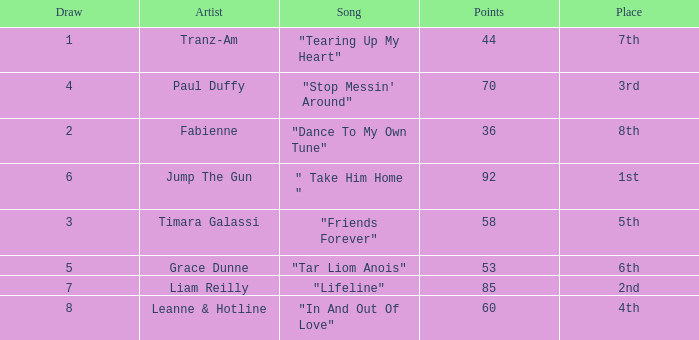Can you parse all the data within this table? {'header': ['Draw', 'Artist', 'Song', 'Points', 'Place'], 'rows': [['1', 'Tranz-Am', '"Tearing Up My Heart"', '44', '7th'], ['4', 'Paul Duffy', '"Stop Messin\' Around"', '70', '3rd'], ['2', 'Fabienne', '"Dance To My Own Tune"', '36', '8th'], ['6', 'Jump The Gun', '" Take Him Home "', '92', '1st'], ['3', 'Timara Galassi', '"Friends Forever"', '58', '5th'], ['5', 'Grace Dunne', '"Tar Liom Anois"', '53', '6th'], ['7', 'Liam Reilly', '"Lifeline"', '85', '2nd'], ['8', 'Leanne & Hotline', '"In And Out Of Love"', '60', '4th']]} What's the average amount of points for "in and out of love" with a draw over 8? None. 